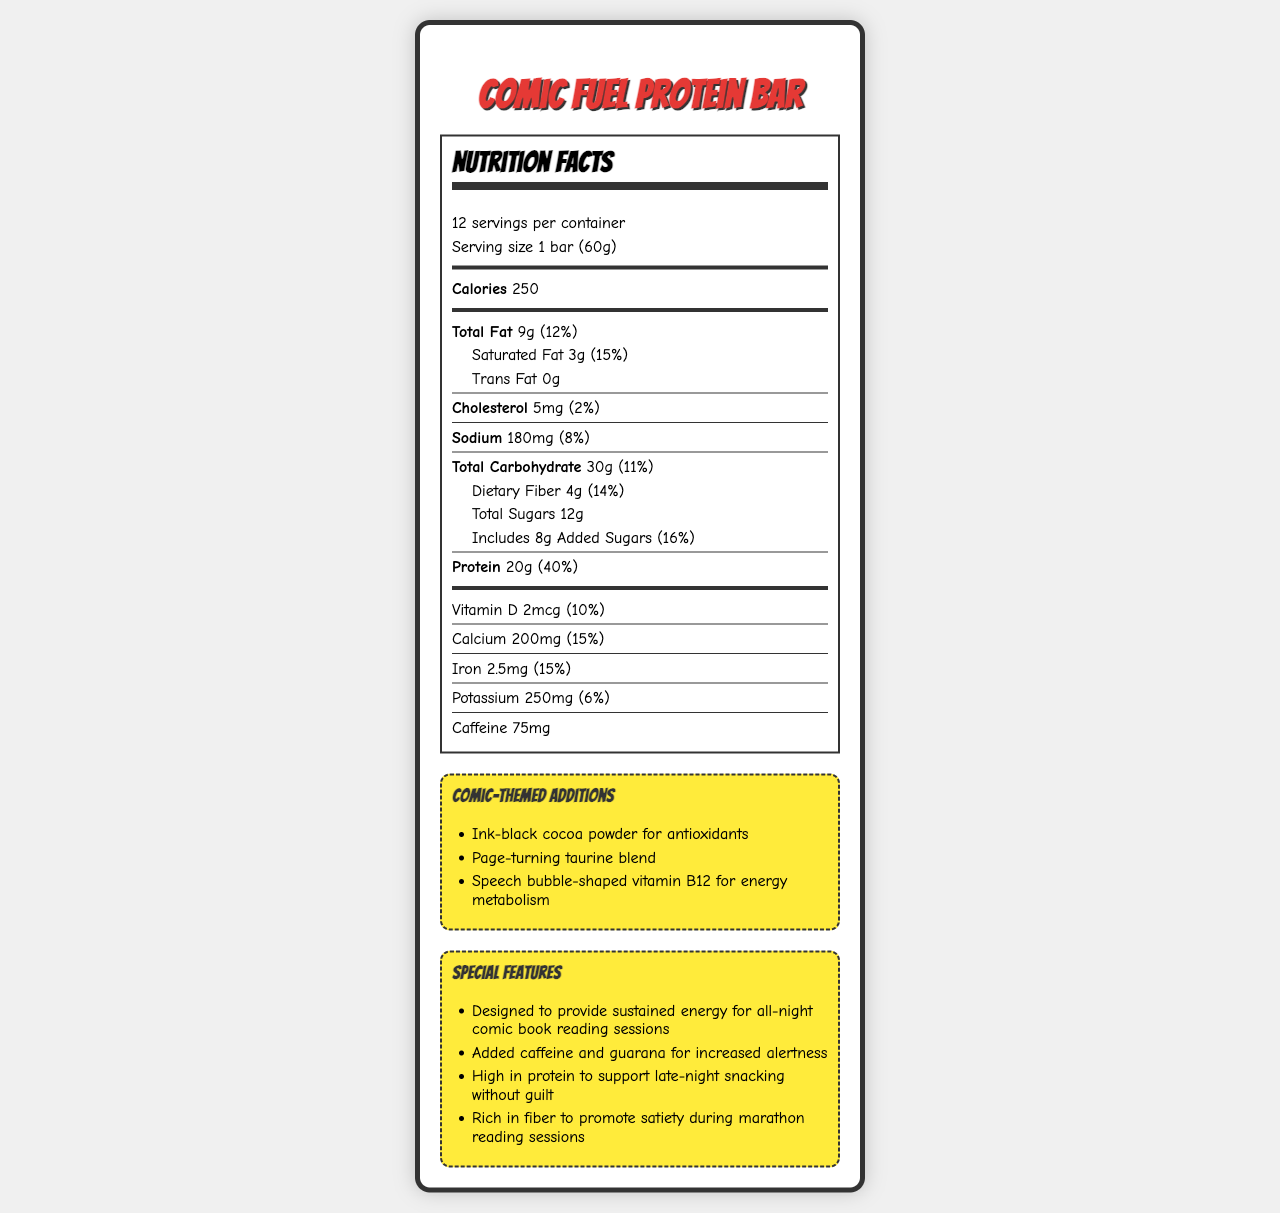what is the serving size of the Comic Fuel Protein Bar? The serving size is clearly mentioned in the document as "1 bar (60g)".
Answer: 1 bar (60g) how many servings are there per container? The document states that there are 12 servings per container.
Answer: 12 how much protein is in one serving? The document mentions that one serving contains 20g of protein.
Answer: 20g what percentage of the daily value of dietary fiber does one serving provide? The dietary fiber daily value for one serving is mentioned as 14%.
Answer: 14% what ingredients are responsible for the caffeine content? The ingredients section lists "Green tea extract" and "Guarana seed extract" which are known sources of caffeine.
Answer: Green tea extract, Guarana seed extract how many total sugars are in one serving? The total amount of sugars per serving is 12g as stated in the document.
Answer: 12g which vitamin is shaped like a speech bubble for energy metabolism? In the comic-themed additions, it mentions "Speech bubble-shaped vitamin B12 for energy metabolism".
Answer: Vitamin B12 how much calcium is in one serving? A. 100mg B. 150mg C. 200mg D. 250mg The document lists the calcium content as 200mg per serving.
Answer: C. 200mg which of the following is NOT a special feature of the Comic Fuel Protein Bar? I. Designed to provide sustained energy II. Added caffeine and guarana III. Low in fat IV. Rich in fiber The document lists "Designed to provide sustained energy," "Added caffeine and guarana," and "Rich in fiber" as special features, but not "Low in fat".
Answer: III. Low in fat can the Comic Fuel Protein Bar be consumed by someone with a peanut allergy? The allergen information states that it is manufactured in a facility that also processes peanuts.
Answer: No is this product suitable for vegetarians? The document does not provide information on whether the product is suitable for vegetarians.
Answer: Cannot be determined how much-added sugar is in one serving? The document states 8g of added sugars in one serving.
Answer: 8g what is the theme of this nutrition label? The design elements and comic-themed additions like "Ink-black cocoa powder," "Page-turning taurine," and "Speech bubble-shaped vitamin B12" indicate a comic book theme.
Answer: Comic book-themed what is the daily value percentage of protein per serving? The document indicates that one serving provides 40% of the daily value for protein.
Answer: 40% summarize the main idea of the document. The document is focused on presenting the nutritional information of a comic-themed protein bar, highlighting its suitability for extended reading sessions, its ingredients, and its additional features aimed at comic enthusiasts.
Answer: The document provides detailed nutrition information for the "Comic Fuel Protein Bar," a high-protein snack designed for sustained energy during all-night comic book reading sessions. It includes detailed nutrient content, comic-themed additions, and special features like added caffeine for increased alertness. Allergen information and key ingredients are also listed. what is the function of the green tea and guarana seed extracts in the product? The special features section mentions that the added caffeine and guarana are meant to increase alertness.
Answer: To increase alertness 